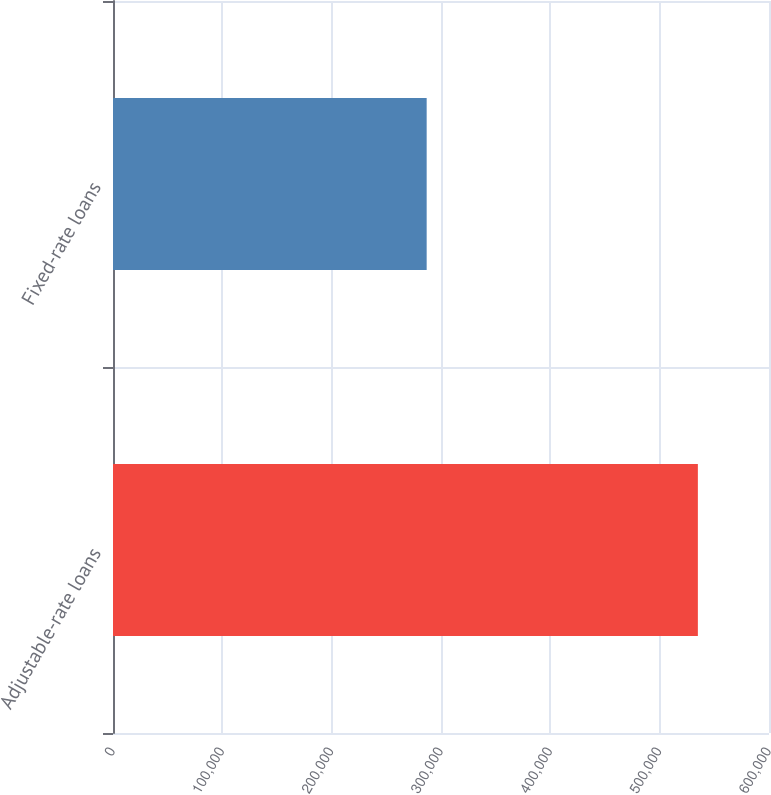Convert chart to OTSL. <chart><loc_0><loc_0><loc_500><loc_500><bar_chart><fcel>Adjustable-rate loans<fcel>Fixed-rate loans<nl><fcel>534943<fcel>286894<nl></chart> 